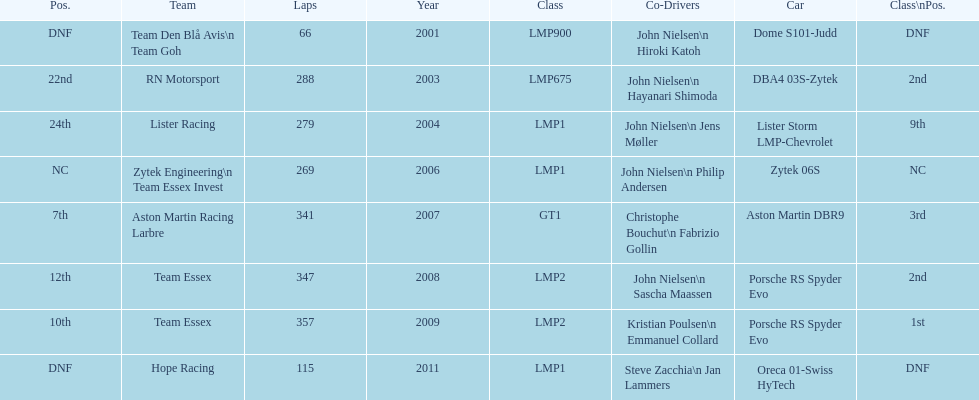What is the amount races that were competed in? 8. 